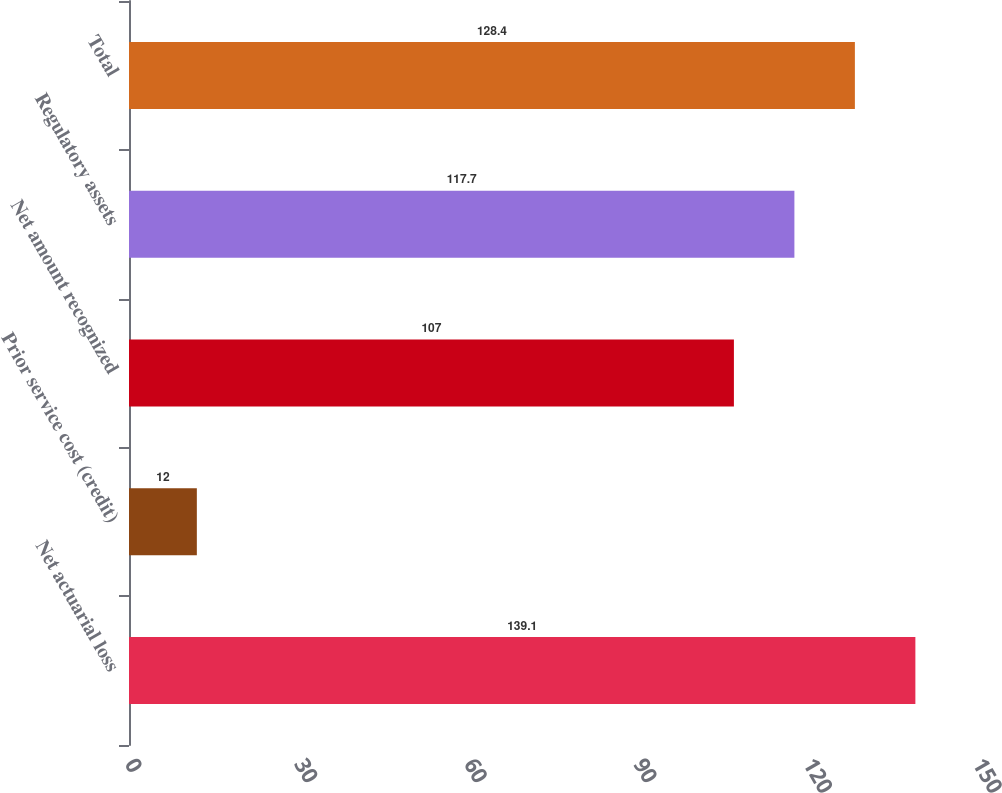Convert chart. <chart><loc_0><loc_0><loc_500><loc_500><bar_chart><fcel>Net actuarial loss<fcel>Prior service cost (credit)<fcel>Net amount recognized<fcel>Regulatory assets<fcel>Total<nl><fcel>139.1<fcel>12<fcel>107<fcel>117.7<fcel>128.4<nl></chart> 